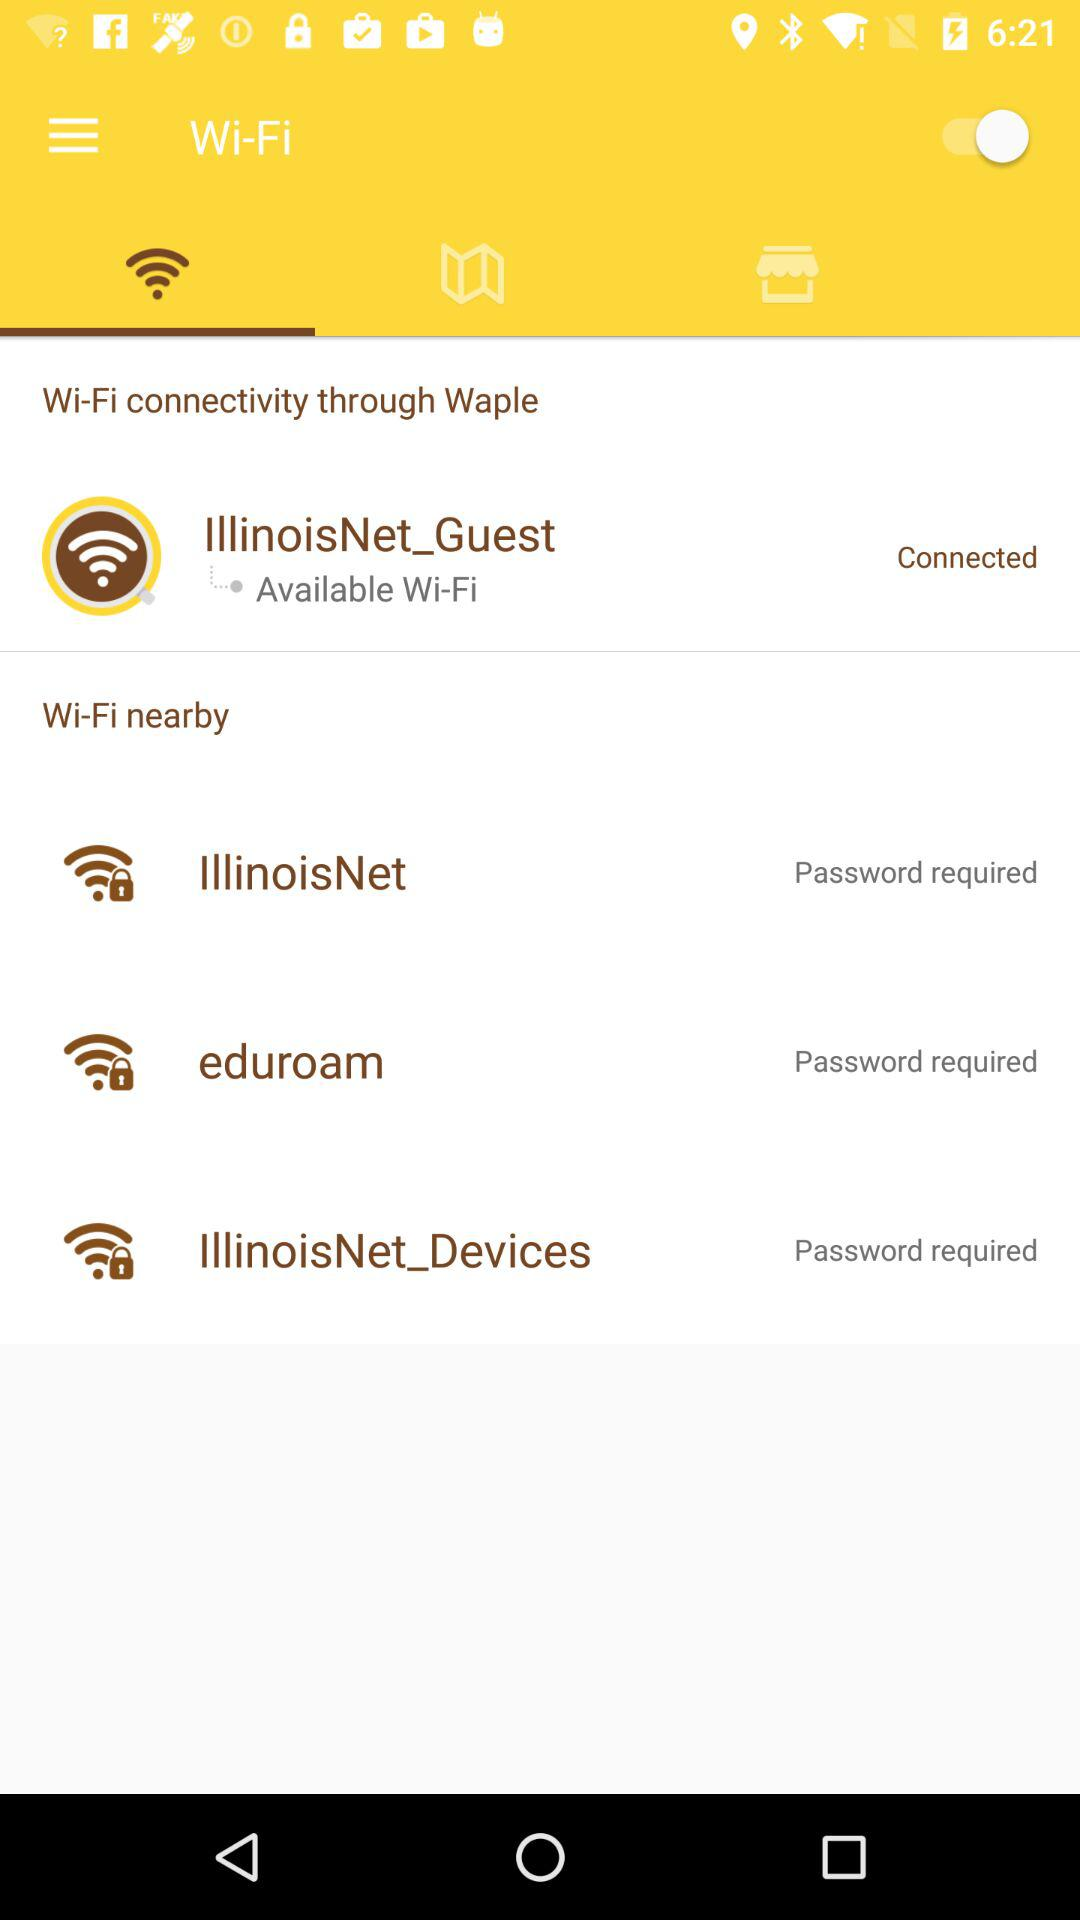Which tab is selected? The selected tab is "Wi-Fi". 